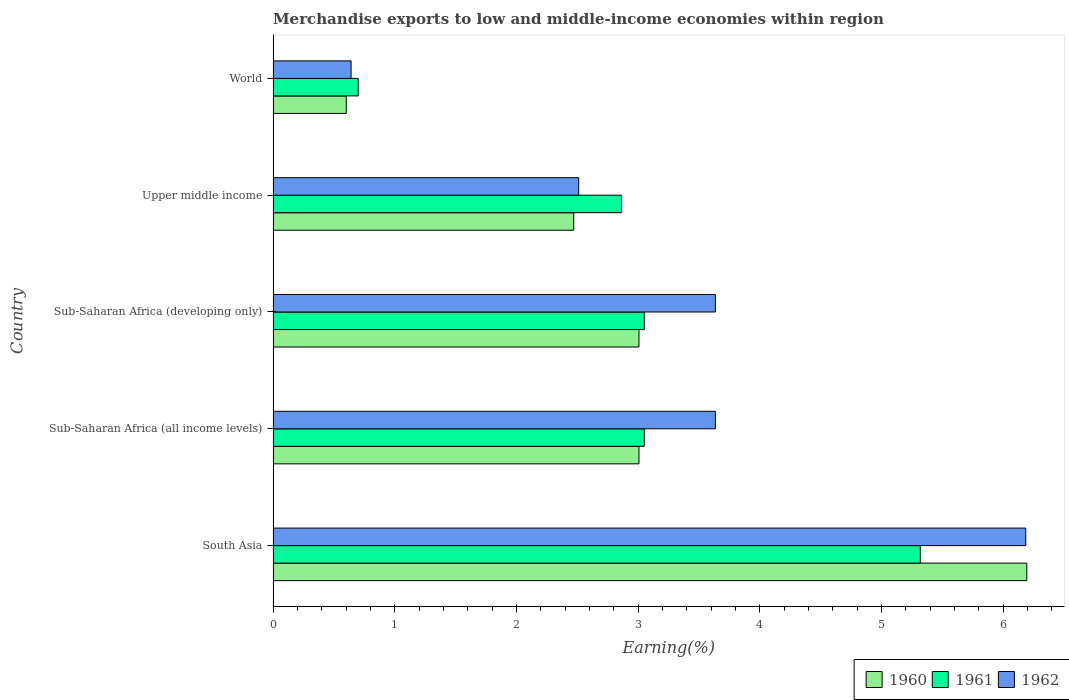How many different coloured bars are there?
Keep it short and to the point. 3. How many groups of bars are there?
Your answer should be very brief. 5. Are the number of bars per tick equal to the number of legend labels?
Provide a short and direct response. Yes. What is the label of the 4th group of bars from the top?
Your answer should be very brief. Sub-Saharan Africa (all income levels). In how many cases, is the number of bars for a given country not equal to the number of legend labels?
Provide a short and direct response. 0. What is the percentage of amount earned from merchandise exports in 1962 in Sub-Saharan Africa (developing only)?
Make the answer very short. 3.63. Across all countries, what is the maximum percentage of amount earned from merchandise exports in 1961?
Ensure brevity in your answer.  5.32. Across all countries, what is the minimum percentage of amount earned from merchandise exports in 1962?
Provide a succinct answer. 0.64. In which country was the percentage of amount earned from merchandise exports in 1961 minimum?
Your answer should be compact. World. What is the total percentage of amount earned from merchandise exports in 1961 in the graph?
Give a very brief answer. 14.98. What is the difference between the percentage of amount earned from merchandise exports in 1960 in South Asia and that in Sub-Saharan Africa (developing only)?
Your answer should be very brief. 3.19. What is the difference between the percentage of amount earned from merchandise exports in 1961 in Sub-Saharan Africa (developing only) and the percentage of amount earned from merchandise exports in 1962 in World?
Offer a terse response. 2.41. What is the average percentage of amount earned from merchandise exports in 1961 per country?
Provide a short and direct response. 3. What is the difference between the percentage of amount earned from merchandise exports in 1962 and percentage of amount earned from merchandise exports in 1960 in Sub-Saharan Africa (developing only)?
Give a very brief answer. 0.63. What is the ratio of the percentage of amount earned from merchandise exports in 1961 in South Asia to that in Sub-Saharan Africa (all income levels)?
Your response must be concise. 1.74. Is the difference between the percentage of amount earned from merchandise exports in 1962 in South Asia and Sub-Saharan Africa (all income levels) greater than the difference between the percentage of amount earned from merchandise exports in 1960 in South Asia and Sub-Saharan Africa (all income levels)?
Provide a succinct answer. No. What is the difference between the highest and the second highest percentage of amount earned from merchandise exports in 1962?
Your response must be concise. 2.55. What is the difference between the highest and the lowest percentage of amount earned from merchandise exports in 1960?
Make the answer very short. 5.59. In how many countries, is the percentage of amount earned from merchandise exports in 1961 greater than the average percentage of amount earned from merchandise exports in 1961 taken over all countries?
Ensure brevity in your answer.  3. What does the 1st bar from the bottom in Sub-Saharan Africa (all income levels) represents?
Provide a short and direct response. 1960. Is it the case that in every country, the sum of the percentage of amount earned from merchandise exports in 1962 and percentage of amount earned from merchandise exports in 1960 is greater than the percentage of amount earned from merchandise exports in 1961?
Offer a very short reply. Yes. Are all the bars in the graph horizontal?
Keep it short and to the point. Yes. How many countries are there in the graph?
Make the answer very short. 5. What is the difference between two consecutive major ticks on the X-axis?
Give a very brief answer. 1. Does the graph contain grids?
Give a very brief answer. No. Where does the legend appear in the graph?
Give a very brief answer. Bottom right. What is the title of the graph?
Make the answer very short. Merchandise exports to low and middle-income economies within region. Does "1977" appear as one of the legend labels in the graph?
Your response must be concise. No. What is the label or title of the X-axis?
Ensure brevity in your answer.  Earning(%). What is the label or title of the Y-axis?
Give a very brief answer. Country. What is the Earning(%) of 1960 in South Asia?
Keep it short and to the point. 6.19. What is the Earning(%) of 1961 in South Asia?
Offer a very short reply. 5.32. What is the Earning(%) in 1962 in South Asia?
Your answer should be very brief. 6.19. What is the Earning(%) in 1960 in Sub-Saharan Africa (all income levels)?
Offer a very short reply. 3.01. What is the Earning(%) of 1961 in Sub-Saharan Africa (all income levels)?
Offer a terse response. 3.05. What is the Earning(%) in 1962 in Sub-Saharan Africa (all income levels)?
Your answer should be compact. 3.63. What is the Earning(%) in 1960 in Sub-Saharan Africa (developing only)?
Make the answer very short. 3.01. What is the Earning(%) in 1961 in Sub-Saharan Africa (developing only)?
Ensure brevity in your answer.  3.05. What is the Earning(%) in 1962 in Sub-Saharan Africa (developing only)?
Provide a short and direct response. 3.63. What is the Earning(%) in 1960 in Upper middle income?
Offer a terse response. 2.47. What is the Earning(%) of 1961 in Upper middle income?
Your answer should be compact. 2.86. What is the Earning(%) of 1962 in Upper middle income?
Your answer should be compact. 2.51. What is the Earning(%) in 1960 in World?
Offer a terse response. 0.6. What is the Earning(%) of 1961 in World?
Your response must be concise. 0.7. What is the Earning(%) of 1962 in World?
Provide a short and direct response. 0.64. Across all countries, what is the maximum Earning(%) in 1960?
Your response must be concise. 6.19. Across all countries, what is the maximum Earning(%) in 1961?
Ensure brevity in your answer.  5.32. Across all countries, what is the maximum Earning(%) in 1962?
Keep it short and to the point. 6.19. Across all countries, what is the minimum Earning(%) in 1960?
Provide a short and direct response. 0.6. Across all countries, what is the minimum Earning(%) of 1961?
Offer a terse response. 0.7. Across all countries, what is the minimum Earning(%) of 1962?
Provide a short and direct response. 0.64. What is the total Earning(%) of 1960 in the graph?
Offer a terse response. 15.28. What is the total Earning(%) in 1961 in the graph?
Offer a very short reply. 14.98. What is the total Earning(%) in 1962 in the graph?
Your answer should be compact. 16.61. What is the difference between the Earning(%) of 1960 in South Asia and that in Sub-Saharan Africa (all income levels)?
Provide a succinct answer. 3.19. What is the difference between the Earning(%) of 1961 in South Asia and that in Sub-Saharan Africa (all income levels)?
Ensure brevity in your answer.  2.27. What is the difference between the Earning(%) in 1962 in South Asia and that in Sub-Saharan Africa (all income levels)?
Offer a very short reply. 2.55. What is the difference between the Earning(%) of 1960 in South Asia and that in Sub-Saharan Africa (developing only)?
Your answer should be very brief. 3.19. What is the difference between the Earning(%) of 1961 in South Asia and that in Sub-Saharan Africa (developing only)?
Your answer should be very brief. 2.27. What is the difference between the Earning(%) in 1962 in South Asia and that in Sub-Saharan Africa (developing only)?
Provide a succinct answer. 2.55. What is the difference between the Earning(%) in 1960 in South Asia and that in Upper middle income?
Give a very brief answer. 3.72. What is the difference between the Earning(%) of 1961 in South Asia and that in Upper middle income?
Provide a short and direct response. 2.46. What is the difference between the Earning(%) of 1962 in South Asia and that in Upper middle income?
Your response must be concise. 3.67. What is the difference between the Earning(%) of 1960 in South Asia and that in World?
Provide a short and direct response. 5.59. What is the difference between the Earning(%) in 1961 in South Asia and that in World?
Your answer should be compact. 4.62. What is the difference between the Earning(%) of 1962 in South Asia and that in World?
Your answer should be compact. 5.54. What is the difference between the Earning(%) of 1962 in Sub-Saharan Africa (all income levels) and that in Sub-Saharan Africa (developing only)?
Give a very brief answer. 0. What is the difference between the Earning(%) in 1960 in Sub-Saharan Africa (all income levels) and that in Upper middle income?
Ensure brevity in your answer.  0.54. What is the difference between the Earning(%) of 1961 in Sub-Saharan Africa (all income levels) and that in Upper middle income?
Provide a succinct answer. 0.19. What is the difference between the Earning(%) of 1962 in Sub-Saharan Africa (all income levels) and that in Upper middle income?
Provide a succinct answer. 1.12. What is the difference between the Earning(%) of 1960 in Sub-Saharan Africa (all income levels) and that in World?
Your answer should be very brief. 2.41. What is the difference between the Earning(%) of 1961 in Sub-Saharan Africa (all income levels) and that in World?
Make the answer very short. 2.35. What is the difference between the Earning(%) in 1962 in Sub-Saharan Africa (all income levels) and that in World?
Your answer should be compact. 2.99. What is the difference between the Earning(%) of 1960 in Sub-Saharan Africa (developing only) and that in Upper middle income?
Provide a succinct answer. 0.54. What is the difference between the Earning(%) of 1961 in Sub-Saharan Africa (developing only) and that in Upper middle income?
Your response must be concise. 0.19. What is the difference between the Earning(%) in 1962 in Sub-Saharan Africa (developing only) and that in Upper middle income?
Offer a terse response. 1.12. What is the difference between the Earning(%) in 1960 in Sub-Saharan Africa (developing only) and that in World?
Make the answer very short. 2.41. What is the difference between the Earning(%) of 1961 in Sub-Saharan Africa (developing only) and that in World?
Offer a terse response. 2.35. What is the difference between the Earning(%) in 1962 in Sub-Saharan Africa (developing only) and that in World?
Your answer should be compact. 2.99. What is the difference between the Earning(%) of 1960 in Upper middle income and that in World?
Offer a terse response. 1.87. What is the difference between the Earning(%) of 1961 in Upper middle income and that in World?
Keep it short and to the point. 2.16. What is the difference between the Earning(%) of 1962 in Upper middle income and that in World?
Make the answer very short. 1.87. What is the difference between the Earning(%) in 1960 in South Asia and the Earning(%) in 1961 in Sub-Saharan Africa (all income levels)?
Keep it short and to the point. 3.14. What is the difference between the Earning(%) of 1960 in South Asia and the Earning(%) of 1962 in Sub-Saharan Africa (all income levels)?
Provide a succinct answer. 2.56. What is the difference between the Earning(%) in 1961 in South Asia and the Earning(%) in 1962 in Sub-Saharan Africa (all income levels)?
Provide a short and direct response. 1.68. What is the difference between the Earning(%) of 1960 in South Asia and the Earning(%) of 1961 in Sub-Saharan Africa (developing only)?
Provide a short and direct response. 3.14. What is the difference between the Earning(%) in 1960 in South Asia and the Earning(%) in 1962 in Sub-Saharan Africa (developing only)?
Give a very brief answer. 2.56. What is the difference between the Earning(%) of 1961 in South Asia and the Earning(%) of 1962 in Sub-Saharan Africa (developing only)?
Your response must be concise. 1.68. What is the difference between the Earning(%) of 1960 in South Asia and the Earning(%) of 1961 in Upper middle income?
Provide a succinct answer. 3.33. What is the difference between the Earning(%) in 1960 in South Asia and the Earning(%) in 1962 in Upper middle income?
Your response must be concise. 3.68. What is the difference between the Earning(%) of 1961 in South Asia and the Earning(%) of 1962 in Upper middle income?
Your answer should be very brief. 2.81. What is the difference between the Earning(%) in 1960 in South Asia and the Earning(%) in 1961 in World?
Offer a very short reply. 5.49. What is the difference between the Earning(%) in 1960 in South Asia and the Earning(%) in 1962 in World?
Offer a terse response. 5.55. What is the difference between the Earning(%) in 1961 in South Asia and the Earning(%) in 1962 in World?
Offer a very short reply. 4.68. What is the difference between the Earning(%) of 1960 in Sub-Saharan Africa (all income levels) and the Earning(%) of 1961 in Sub-Saharan Africa (developing only)?
Keep it short and to the point. -0.04. What is the difference between the Earning(%) in 1960 in Sub-Saharan Africa (all income levels) and the Earning(%) in 1962 in Sub-Saharan Africa (developing only)?
Give a very brief answer. -0.63. What is the difference between the Earning(%) of 1961 in Sub-Saharan Africa (all income levels) and the Earning(%) of 1962 in Sub-Saharan Africa (developing only)?
Your answer should be very brief. -0.58. What is the difference between the Earning(%) of 1960 in Sub-Saharan Africa (all income levels) and the Earning(%) of 1961 in Upper middle income?
Give a very brief answer. 0.14. What is the difference between the Earning(%) in 1960 in Sub-Saharan Africa (all income levels) and the Earning(%) in 1962 in Upper middle income?
Keep it short and to the point. 0.5. What is the difference between the Earning(%) of 1961 in Sub-Saharan Africa (all income levels) and the Earning(%) of 1962 in Upper middle income?
Offer a very short reply. 0.54. What is the difference between the Earning(%) of 1960 in Sub-Saharan Africa (all income levels) and the Earning(%) of 1961 in World?
Your answer should be very brief. 2.31. What is the difference between the Earning(%) of 1960 in Sub-Saharan Africa (all income levels) and the Earning(%) of 1962 in World?
Make the answer very short. 2.37. What is the difference between the Earning(%) of 1961 in Sub-Saharan Africa (all income levels) and the Earning(%) of 1962 in World?
Offer a terse response. 2.41. What is the difference between the Earning(%) of 1960 in Sub-Saharan Africa (developing only) and the Earning(%) of 1961 in Upper middle income?
Give a very brief answer. 0.14. What is the difference between the Earning(%) in 1960 in Sub-Saharan Africa (developing only) and the Earning(%) in 1962 in Upper middle income?
Give a very brief answer. 0.5. What is the difference between the Earning(%) in 1961 in Sub-Saharan Africa (developing only) and the Earning(%) in 1962 in Upper middle income?
Give a very brief answer. 0.54. What is the difference between the Earning(%) in 1960 in Sub-Saharan Africa (developing only) and the Earning(%) in 1961 in World?
Keep it short and to the point. 2.31. What is the difference between the Earning(%) in 1960 in Sub-Saharan Africa (developing only) and the Earning(%) in 1962 in World?
Provide a succinct answer. 2.37. What is the difference between the Earning(%) of 1961 in Sub-Saharan Africa (developing only) and the Earning(%) of 1962 in World?
Provide a succinct answer. 2.41. What is the difference between the Earning(%) in 1960 in Upper middle income and the Earning(%) in 1961 in World?
Make the answer very short. 1.77. What is the difference between the Earning(%) of 1960 in Upper middle income and the Earning(%) of 1962 in World?
Offer a very short reply. 1.83. What is the difference between the Earning(%) in 1961 in Upper middle income and the Earning(%) in 1962 in World?
Your answer should be very brief. 2.22. What is the average Earning(%) in 1960 per country?
Your answer should be compact. 3.06. What is the average Earning(%) of 1961 per country?
Ensure brevity in your answer.  3. What is the average Earning(%) in 1962 per country?
Your answer should be very brief. 3.32. What is the difference between the Earning(%) of 1960 and Earning(%) of 1961 in South Asia?
Make the answer very short. 0.88. What is the difference between the Earning(%) in 1960 and Earning(%) in 1962 in South Asia?
Your answer should be very brief. 0.01. What is the difference between the Earning(%) in 1961 and Earning(%) in 1962 in South Asia?
Make the answer very short. -0.87. What is the difference between the Earning(%) of 1960 and Earning(%) of 1961 in Sub-Saharan Africa (all income levels)?
Provide a succinct answer. -0.04. What is the difference between the Earning(%) in 1960 and Earning(%) in 1962 in Sub-Saharan Africa (all income levels)?
Provide a short and direct response. -0.63. What is the difference between the Earning(%) in 1961 and Earning(%) in 1962 in Sub-Saharan Africa (all income levels)?
Ensure brevity in your answer.  -0.58. What is the difference between the Earning(%) in 1960 and Earning(%) in 1961 in Sub-Saharan Africa (developing only)?
Provide a succinct answer. -0.04. What is the difference between the Earning(%) of 1960 and Earning(%) of 1962 in Sub-Saharan Africa (developing only)?
Offer a terse response. -0.63. What is the difference between the Earning(%) of 1961 and Earning(%) of 1962 in Sub-Saharan Africa (developing only)?
Give a very brief answer. -0.58. What is the difference between the Earning(%) in 1960 and Earning(%) in 1961 in Upper middle income?
Provide a succinct answer. -0.39. What is the difference between the Earning(%) of 1960 and Earning(%) of 1962 in Upper middle income?
Give a very brief answer. -0.04. What is the difference between the Earning(%) of 1961 and Earning(%) of 1962 in Upper middle income?
Offer a terse response. 0.35. What is the difference between the Earning(%) of 1960 and Earning(%) of 1961 in World?
Give a very brief answer. -0.1. What is the difference between the Earning(%) in 1960 and Earning(%) in 1962 in World?
Your answer should be compact. -0.04. What is the difference between the Earning(%) of 1961 and Earning(%) of 1962 in World?
Offer a very short reply. 0.06. What is the ratio of the Earning(%) in 1960 in South Asia to that in Sub-Saharan Africa (all income levels)?
Keep it short and to the point. 2.06. What is the ratio of the Earning(%) of 1961 in South Asia to that in Sub-Saharan Africa (all income levels)?
Ensure brevity in your answer.  1.74. What is the ratio of the Earning(%) of 1962 in South Asia to that in Sub-Saharan Africa (all income levels)?
Keep it short and to the point. 1.7. What is the ratio of the Earning(%) in 1960 in South Asia to that in Sub-Saharan Africa (developing only)?
Give a very brief answer. 2.06. What is the ratio of the Earning(%) in 1961 in South Asia to that in Sub-Saharan Africa (developing only)?
Make the answer very short. 1.74. What is the ratio of the Earning(%) of 1962 in South Asia to that in Sub-Saharan Africa (developing only)?
Provide a succinct answer. 1.7. What is the ratio of the Earning(%) of 1960 in South Asia to that in Upper middle income?
Make the answer very short. 2.51. What is the ratio of the Earning(%) in 1961 in South Asia to that in Upper middle income?
Offer a very short reply. 1.86. What is the ratio of the Earning(%) in 1962 in South Asia to that in Upper middle income?
Your response must be concise. 2.46. What is the ratio of the Earning(%) of 1960 in South Asia to that in World?
Your answer should be compact. 10.3. What is the ratio of the Earning(%) in 1961 in South Asia to that in World?
Ensure brevity in your answer.  7.61. What is the ratio of the Earning(%) in 1962 in South Asia to that in World?
Offer a very short reply. 9.65. What is the ratio of the Earning(%) in 1962 in Sub-Saharan Africa (all income levels) to that in Sub-Saharan Africa (developing only)?
Your response must be concise. 1. What is the ratio of the Earning(%) in 1960 in Sub-Saharan Africa (all income levels) to that in Upper middle income?
Ensure brevity in your answer.  1.22. What is the ratio of the Earning(%) of 1961 in Sub-Saharan Africa (all income levels) to that in Upper middle income?
Your response must be concise. 1.07. What is the ratio of the Earning(%) of 1962 in Sub-Saharan Africa (all income levels) to that in Upper middle income?
Provide a succinct answer. 1.45. What is the ratio of the Earning(%) of 1960 in Sub-Saharan Africa (all income levels) to that in World?
Give a very brief answer. 5. What is the ratio of the Earning(%) of 1961 in Sub-Saharan Africa (all income levels) to that in World?
Your response must be concise. 4.36. What is the ratio of the Earning(%) of 1962 in Sub-Saharan Africa (all income levels) to that in World?
Your answer should be very brief. 5.67. What is the ratio of the Earning(%) of 1960 in Sub-Saharan Africa (developing only) to that in Upper middle income?
Your response must be concise. 1.22. What is the ratio of the Earning(%) in 1961 in Sub-Saharan Africa (developing only) to that in Upper middle income?
Provide a succinct answer. 1.07. What is the ratio of the Earning(%) in 1962 in Sub-Saharan Africa (developing only) to that in Upper middle income?
Make the answer very short. 1.45. What is the ratio of the Earning(%) in 1960 in Sub-Saharan Africa (developing only) to that in World?
Offer a terse response. 5. What is the ratio of the Earning(%) in 1961 in Sub-Saharan Africa (developing only) to that in World?
Ensure brevity in your answer.  4.36. What is the ratio of the Earning(%) in 1962 in Sub-Saharan Africa (developing only) to that in World?
Provide a short and direct response. 5.67. What is the ratio of the Earning(%) of 1960 in Upper middle income to that in World?
Keep it short and to the point. 4.11. What is the ratio of the Earning(%) in 1961 in Upper middle income to that in World?
Offer a very short reply. 4.09. What is the ratio of the Earning(%) of 1962 in Upper middle income to that in World?
Your response must be concise. 3.92. What is the difference between the highest and the second highest Earning(%) in 1960?
Keep it short and to the point. 3.19. What is the difference between the highest and the second highest Earning(%) in 1961?
Your answer should be very brief. 2.27. What is the difference between the highest and the second highest Earning(%) of 1962?
Your answer should be compact. 2.55. What is the difference between the highest and the lowest Earning(%) of 1960?
Your answer should be very brief. 5.59. What is the difference between the highest and the lowest Earning(%) of 1961?
Ensure brevity in your answer.  4.62. What is the difference between the highest and the lowest Earning(%) in 1962?
Give a very brief answer. 5.54. 